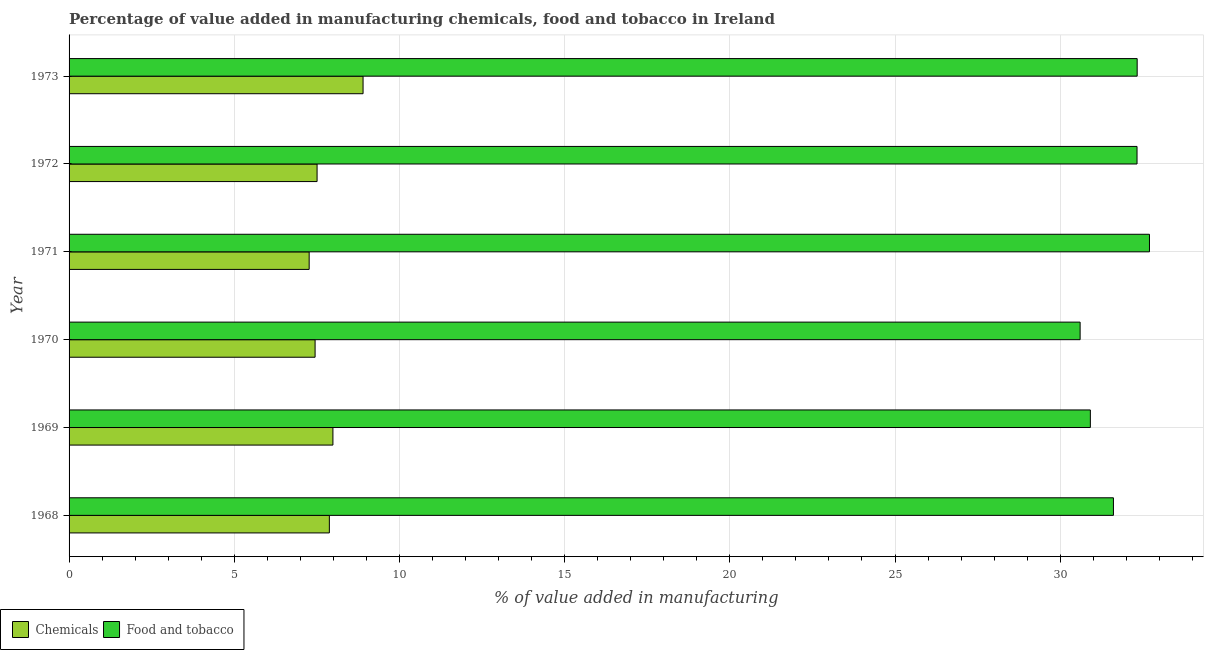Are the number of bars on each tick of the Y-axis equal?
Your response must be concise. Yes. How many bars are there on the 5th tick from the top?
Offer a very short reply. 2. What is the label of the 4th group of bars from the top?
Give a very brief answer. 1970. What is the value added by manufacturing food and tobacco in 1972?
Make the answer very short. 32.33. Across all years, what is the maximum value added by manufacturing food and tobacco?
Ensure brevity in your answer.  32.7. Across all years, what is the minimum value added by  manufacturing chemicals?
Provide a succinct answer. 7.27. In which year was the value added by  manufacturing chemicals minimum?
Offer a very short reply. 1971. What is the total value added by manufacturing food and tobacco in the graph?
Your answer should be very brief. 190.49. What is the difference between the value added by  manufacturing chemicals in 1972 and that in 1973?
Provide a short and direct response. -1.39. What is the difference between the value added by manufacturing food and tobacco in 1971 and the value added by  manufacturing chemicals in 1973?
Provide a short and direct response. 23.8. What is the average value added by manufacturing food and tobacco per year?
Offer a very short reply. 31.75. In the year 1971, what is the difference between the value added by manufacturing food and tobacco and value added by  manufacturing chemicals?
Give a very brief answer. 25.43. Is the difference between the value added by manufacturing food and tobacco in 1968 and 1971 greater than the difference between the value added by  manufacturing chemicals in 1968 and 1971?
Provide a short and direct response. No. What is the difference between the highest and the second highest value added by manufacturing food and tobacco?
Offer a terse response. 0.37. What is the difference between the highest and the lowest value added by manufacturing food and tobacco?
Your answer should be compact. 2.1. What does the 2nd bar from the top in 1970 represents?
Keep it short and to the point. Chemicals. What does the 1st bar from the bottom in 1972 represents?
Offer a very short reply. Chemicals. How many bars are there?
Provide a succinct answer. 12. How many years are there in the graph?
Offer a very short reply. 6. What is the difference between two consecutive major ticks on the X-axis?
Provide a short and direct response. 5. Does the graph contain any zero values?
Your answer should be very brief. No. Does the graph contain grids?
Provide a short and direct response. Yes. Where does the legend appear in the graph?
Provide a short and direct response. Bottom left. How many legend labels are there?
Give a very brief answer. 2. How are the legend labels stacked?
Ensure brevity in your answer.  Horizontal. What is the title of the graph?
Offer a terse response. Percentage of value added in manufacturing chemicals, food and tobacco in Ireland. What is the label or title of the X-axis?
Keep it short and to the point. % of value added in manufacturing. What is the label or title of the Y-axis?
Keep it short and to the point. Year. What is the % of value added in manufacturing in Chemicals in 1968?
Your answer should be very brief. 7.88. What is the % of value added in manufacturing of Food and tobacco in 1968?
Give a very brief answer. 31.61. What is the % of value added in manufacturing in Chemicals in 1969?
Ensure brevity in your answer.  7.99. What is the % of value added in manufacturing of Food and tobacco in 1969?
Your answer should be very brief. 30.91. What is the % of value added in manufacturing in Chemicals in 1970?
Give a very brief answer. 7.45. What is the % of value added in manufacturing of Food and tobacco in 1970?
Give a very brief answer. 30.6. What is the % of value added in manufacturing of Chemicals in 1971?
Keep it short and to the point. 7.27. What is the % of value added in manufacturing in Food and tobacco in 1971?
Make the answer very short. 32.7. What is the % of value added in manufacturing of Chemicals in 1972?
Provide a succinct answer. 7.51. What is the % of value added in manufacturing of Food and tobacco in 1972?
Your answer should be compact. 32.33. What is the % of value added in manufacturing in Chemicals in 1973?
Keep it short and to the point. 8.9. What is the % of value added in manufacturing of Food and tobacco in 1973?
Offer a terse response. 32.33. Across all years, what is the maximum % of value added in manufacturing in Chemicals?
Ensure brevity in your answer.  8.9. Across all years, what is the maximum % of value added in manufacturing in Food and tobacco?
Ensure brevity in your answer.  32.7. Across all years, what is the minimum % of value added in manufacturing in Chemicals?
Your answer should be very brief. 7.27. Across all years, what is the minimum % of value added in manufacturing of Food and tobacco?
Your response must be concise. 30.6. What is the total % of value added in manufacturing in Chemicals in the graph?
Provide a succinct answer. 46.99. What is the total % of value added in manufacturing in Food and tobacco in the graph?
Keep it short and to the point. 190.49. What is the difference between the % of value added in manufacturing of Chemicals in 1968 and that in 1969?
Your answer should be very brief. -0.11. What is the difference between the % of value added in manufacturing in Food and tobacco in 1968 and that in 1969?
Make the answer very short. 0.7. What is the difference between the % of value added in manufacturing of Chemicals in 1968 and that in 1970?
Ensure brevity in your answer.  0.43. What is the difference between the % of value added in manufacturing in Food and tobacco in 1968 and that in 1970?
Provide a short and direct response. 1.01. What is the difference between the % of value added in manufacturing of Chemicals in 1968 and that in 1971?
Offer a very short reply. 0.61. What is the difference between the % of value added in manufacturing of Food and tobacco in 1968 and that in 1971?
Provide a short and direct response. -1.09. What is the difference between the % of value added in manufacturing of Chemicals in 1968 and that in 1972?
Provide a succinct answer. 0.37. What is the difference between the % of value added in manufacturing of Food and tobacco in 1968 and that in 1972?
Your response must be concise. -0.71. What is the difference between the % of value added in manufacturing of Chemicals in 1968 and that in 1973?
Your response must be concise. -1.02. What is the difference between the % of value added in manufacturing of Food and tobacco in 1968 and that in 1973?
Provide a succinct answer. -0.72. What is the difference between the % of value added in manufacturing in Chemicals in 1969 and that in 1970?
Your answer should be very brief. 0.54. What is the difference between the % of value added in manufacturing of Food and tobacco in 1969 and that in 1970?
Keep it short and to the point. 0.31. What is the difference between the % of value added in manufacturing of Chemicals in 1969 and that in 1971?
Make the answer very short. 0.72. What is the difference between the % of value added in manufacturing of Food and tobacco in 1969 and that in 1971?
Provide a succinct answer. -1.79. What is the difference between the % of value added in manufacturing of Chemicals in 1969 and that in 1972?
Provide a short and direct response. 0.48. What is the difference between the % of value added in manufacturing in Food and tobacco in 1969 and that in 1972?
Offer a very short reply. -1.41. What is the difference between the % of value added in manufacturing of Chemicals in 1969 and that in 1973?
Ensure brevity in your answer.  -0.91. What is the difference between the % of value added in manufacturing in Food and tobacco in 1969 and that in 1973?
Provide a short and direct response. -1.42. What is the difference between the % of value added in manufacturing in Chemicals in 1970 and that in 1971?
Provide a short and direct response. 0.18. What is the difference between the % of value added in manufacturing of Food and tobacco in 1970 and that in 1971?
Make the answer very short. -2.1. What is the difference between the % of value added in manufacturing of Chemicals in 1970 and that in 1972?
Offer a very short reply. -0.06. What is the difference between the % of value added in manufacturing of Food and tobacco in 1970 and that in 1972?
Offer a very short reply. -1.72. What is the difference between the % of value added in manufacturing of Chemicals in 1970 and that in 1973?
Keep it short and to the point. -1.45. What is the difference between the % of value added in manufacturing in Food and tobacco in 1970 and that in 1973?
Give a very brief answer. -1.73. What is the difference between the % of value added in manufacturing in Chemicals in 1971 and that in 1972?
Provide a succinct answer. -0.24. What is the difference between the % of value added in manufacturing in Food and tobacco in 1971 and that in 1972?
Your response must be concise. 0.38. What is the difference between the % of value added in manufacturing of Chemicals in 1971 and that in 1973?
Your response must be concise. -1.63. What is the difference between the % of value added in manufacturing in Food and tobacco in 1971 and that in 1973?
Your response must be concise. 0.37. What is the difference between the % of value added in manufacturing in Chemicals in 1972 and that in 1973?
Provide a succinct answer. -1.39. What is the difference between the % of value added in manufacturing of Food and tobacco in 1972 and that in 1973?
Ensure brevity in your answer.  -0. What is the difference between the % of value added in manufacturing of Chemicals in 1968 and the % of value added in manufacturing of Food and tobacco in 1969?
Offer a very short reply. -23.03. What is the difference between the % of value added in manufacturing in Chemicals in 1968 and the % of value added in manufacturing in Food and tobacco in 1970?
Ensure brevity in your answer.  -22.73. What is the difference between the % of value added in manufacturing in Chemicals in 1968 and the % of value added in manufacturing in Food and tobacco in 1971?
Provide a short and direct response. -24.82. What is the difference between the % of value added in manufacturing of Chemicals in 1968 and the % of value added in manufacturing of Food and tobacco in 1972?
Your response must be concise. -24.45. What is the difference between the % of value added in manufacturing in Chemicals in 1968 and the % of value added in manufacturing in Food and tobacco in 1973?
Keep it short and to the point. -24.45. What is the difference between the % of value added in manufacturing in Chemicals in 1969 and the % of value added in manufacturing in Food and tobacco in 1970?
Give a very brief answer. -22.62. What is the difference between the % of value added in manufacturing in Chemicals in 1969 and the % of value added in manufacturing in Food and tobacco in 1971?
Your answer should be very brief. -24.72. What is the difference between the % of value added in manufacturing in Chemicals in 1969 and the % of value added in manufacturing in Food and tobacco in 1972?
Ensure brevity in your answer.  -24.34. What is the difference between the % of value added in manufacturing in Chemicals in 1969 and the % of value added in manufacturing in Food and tobacco in 1973?
Your answer should be compact. -24.34. What is the difference between the % of value added in manufacturing of Chemicals in 1970 and the % of value added in manufacturing of Food and tobacco in 1971?
Your answer should be compact. -25.26. What is the difference between the % of value added in manufacturing of Chemicals in 1970 and the % of value added in manufacturing of Food and tobacco in 1972?
Provide a succinct answer. -24.88. What is the difference between the % of value added in manufacturing of Chemicals in 1970 and the % of value added in manufacturing of Food and tobacco in 1973?
Ensure brevity in your answer.  -24.88. What is the difference between the % of value added in manufacturing of Chemicals in 1971 and the % of value added in manufacturing of Food and tobacco in 1972?
Offer a terse response. -25.06. What is the difference between the % of value added in manufacturing in Chemicals in 1971 and the % of value added in manufacturing in Food and tobacco in 1973?
Make the answer very short. -25.06. What is the difference between the % of value added in manufacturing in Chemicals in 1972 and the % of value added in manufacturing in Food and tobacco in 1973?
Offer a terse response. -24.82. What is the average % of value added in manufacturing of Chemicals per year?
Make the answer very short. 7.83. What is the average % of value added in manufacturing in Food and tobacco per year?
Provide a succinct answer. 31.75. In the year 1968, what is the difference between the % of value added in manufacturing of Chemicals and % of value added in manufacturing of Food and tobacco?
Make the answer very short. -23.73. In the year 1969, what is the difference between the % of value added in manufacturing of Chemicals and % of value added in manufacturing of Food and tobacco?
Offer a terse response. -22.93. In the year 1970, what is the difference between the % of value added in manufacturing in Chemicals and % of value added in manufacturing in Food and tobacco?
Give a very brief answer. -23.16. In the year 1971, what is the difference between the % of value added in manufacturing in Chemicals and % of value added in manufacturing in Food and tobacco?
Your response must be concise. -25.44. In the year 1972, what is the difference between the % of value added in manufacturing of Chemicals and % of value added in manufacturing of Food and tobacco?
Your answer should be compact. -24.82. In the year 1973, what is the difference between the % of value added in manufacturing of Chemicals and % of value added in manufacturing of Food and tobacco?
Provide a short and direct response. -23.43. What is the ratio of the % of value added in manufacturing in Chemicals in 1968 to that in 1969?
Ensure brevity in your answer.  0.99. What is the ratio of the % of value added in manufacturing in Food and tobacco in 1968 to that in 1969?
Provide a short and direct response. 1.02. What is the ratio of the % of value added in manufacturing in Chemicals in 1968 to that in 1970?
Make the answer very short. 1.06. What is the ratio of the % of value added in manufacturing in Food and tobacco in 1968 to that in 1970?
Make the answer very short. 1.03. What is the ratio of the % of value added in manufacturing of Chemicals in 1968 to that in 1971?
Your answer should be very brief. 1.08. What is the ratio of the % of value added in manufacturing of Food and tobacco in 1968 to that in 1971?
Provide a short and direct response. 0.97. What is the ratio of the % of value added in manufacturing of Chemicals in 1968 to that in 1972?
Give a very brief answer. 1.05. What is the ratio of the % of value added in manufacturing in Food and tobacco in 1968 to that in 1972?
Offer a very short reply. 0.98. What is the ratio of the % of value added in manufacturing of Chemicals in 1968 to that in 1973?
Ensure brevity in your answer.  0.89. What is the ratio of the % of value added in manufacturing of Food and tobacco in 1968 to that in 1973?
Your answer should be compact. 0.98. What is the ratio of the % of value added in manufacturing in Chemicals in 1969 to that in 1970?
Your answer should be very brief. 1.07. What is the ratio of the % of value added in manufacturing in Chemicals in 1969 to that in 1971?
Provide a succinct answer. 1.1. What is the ratio of the % of value added in manufacturing of Food and tobacco in 1969 to that in 1971?
Keep it short and to the point. 0.95. What is the ratio of the % of value added in manufacturing in Chemicals in 1969 to that in 1972?
Offer a terse response. 1.06. What is the ratio of the % of value added in manufacturing of Food and tobacco in 1969 to that in 1972?
Keep it short and to the point. 0.96. What is the ratio of the % of value added in manufacturing of Chemicals in 1969 to that in 1973?
Your response must be concise. 0.9. What is the ratio of the % of value added in manufacturing of Food and tobacco in 1969 to that in 1973?
Your answer should be compact. 0.96. What is the ratio of the % of value added in manufacturing of Chemicals in 1970 to that in 1971?
Offer a very short reply. 1.02. What is the ratio of the % of value added in manufacturing in Food and tobacco in 1970 to that in 1971?
Provide a succinct answer. 0.94. What is the ratio of the % of value added in manufacturing of Food and tobacco in 1970 to that in 1972?
Offer a very short reply. 0.95. What is the ratio of the % of value added in manufacturing of Chemicals in 1970 to that in 1973?
Give a very brief answer. 0.84. What is the ratio of the % of value added in manufacturing in Food and tobacco in 1970 to that in 1973?
Keep it short and to the point. 0.95. What is the ratio of the % of value added in manufacturing of Chemicals in 1971 to that in 1972?
Make the answer very short. 0.97. What is the ratio of the % of value added in manufacturing of Food and tobacco in 1971 to that in 1972?
Give a very brief answer. 1.01. What is the ratio of the % of value added in manufacturing in Chemicals in 1971 to that in 1973?
Your answer should be compact. 0.82. What is the ratio of the % of value added in manufacturing in Food and tobacco in 1971 to that in 1973?
Give a very brief answer. 1.01. What is the ratio of the % of value added in manufacturing of Chemicals in 1972 to that in 1973?
Your response must be concise. 0.84. What is the ratio of the % of value added in manufacturing in Food and tobacco in 1972 to that in 1973?
Your response must be concise. 1. What is the difference between the highest and the second highest % of value added in manufacturing of Chemicals?
Provide a succinct answer. 0.91. What is the difference between the highest and the second highest % of value added in manufacturing of Food and tobacco?
Ensure brevity in your answer.  0.37. What is the difference between the highest and the lowest % of value added in manufacturing in Chemicals?
Make the answer very short. 1.63. What is the difference between the highest and the lowest % of value added in manufacturing in Food and tobacco?
Give a very brief answer. 2.1. 